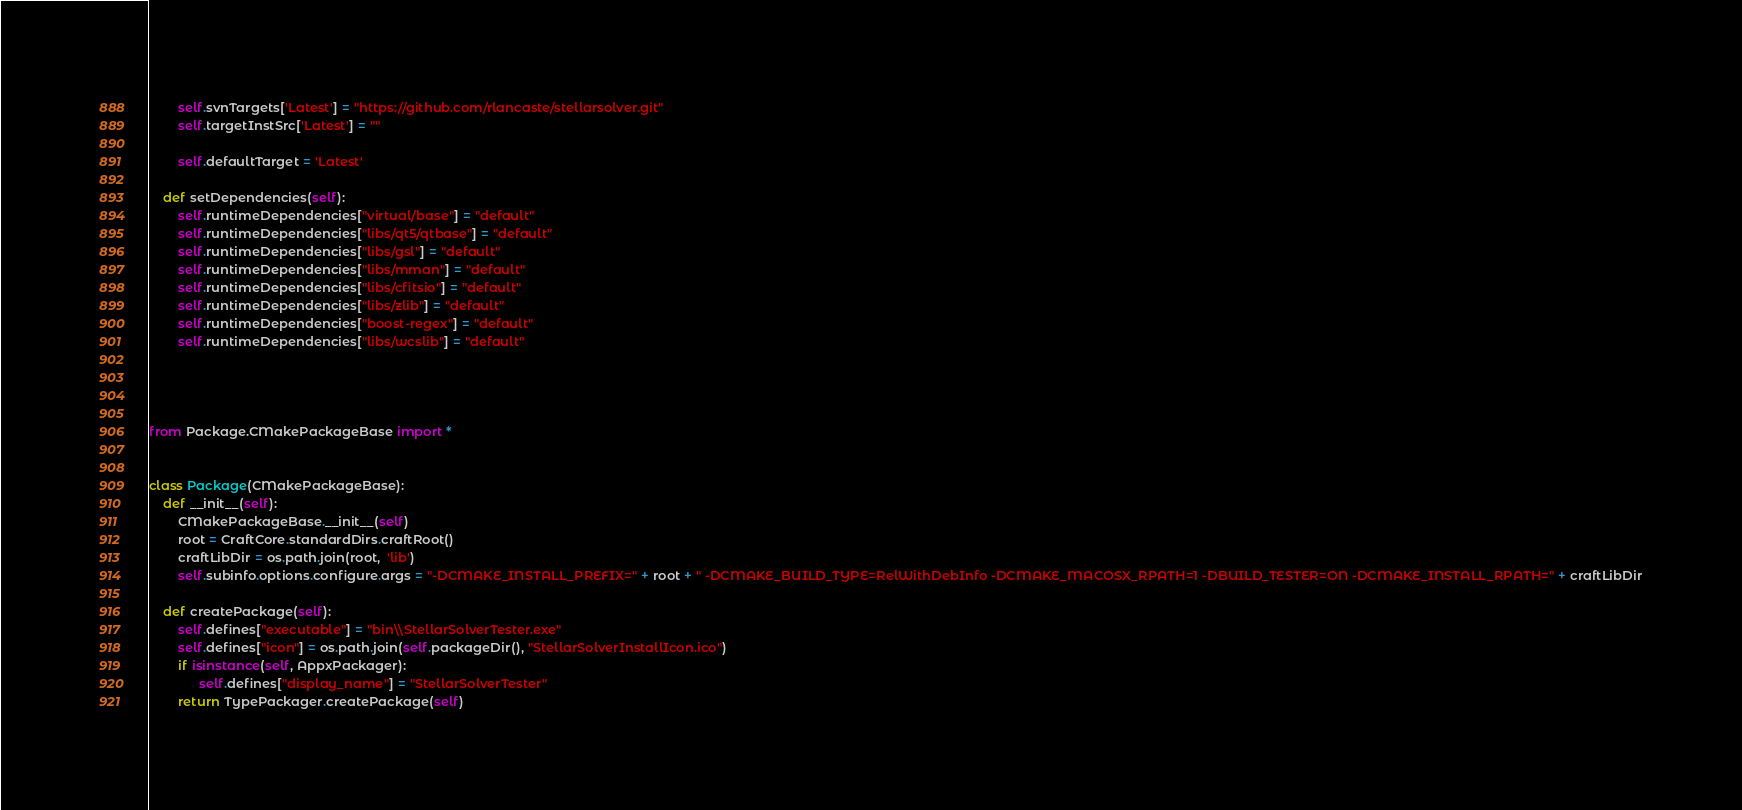<code> <loc_0><loc_0><loc_500><loc_500><_Python_>        self.svnTargets['Latest'] = "https://github.com/rlancaste/stellarsolver.git"
        self.targetInstSrc['Latest'] = ""

        self.defaultTarget = 'Latest'
    
    def setDependencies(self):
        self.runtimeDependencies["virtual/base"] = "default"
        self.runtimeDependencies["libs/qt5/qtbase"] = "default"
        self.runtimeDependencies["libs/gsl"] = "default"
        self.runtimeDependencies["libs/mman"] = "default"
        self.runtimeDependencies["libs/cfitsio"] = "default"
        self.runtimeDependencies["libs/zlib"] = "default"
        self.runtimeDependencies["boost-regex"] = "default"
        self.runtimeDependencies["libs/wcslib"] = "default"




from Package.CMakePackageBase import *


class Package(CMakePackageBase):
    def __init__(self):
        CMakePackageBase.__init__(self)
        root = CraftCore.standardDirs.craftRoot()
        craftLibDir = os.path.join(root,  'lib')
        self.subinfo.options.configure.args = "-DCMAKE_INSTALL_PREFIX=" + root + " -DCMAKE_BUILD_TYPE=RelWithDebInfo -DCMAKE_MACOSX_RPATH=1 -DBUILD_TESTER=ON -DCMAKE_INSTALL_RPATH=" + craftLibDir

    def createPackage(self):
        self.defines["executable"] = "bin\\StellarSolverTester.exe"
        self.defines["icon"] = os.path.join(self.packageDir(), "StellarSolverInstallIcon.ico")
        if isinstance(self, AppxPackager):
              self.defines["display_name"] = "StellarSolverTester"
        return TypePackager.createPackage(self)
</code> 